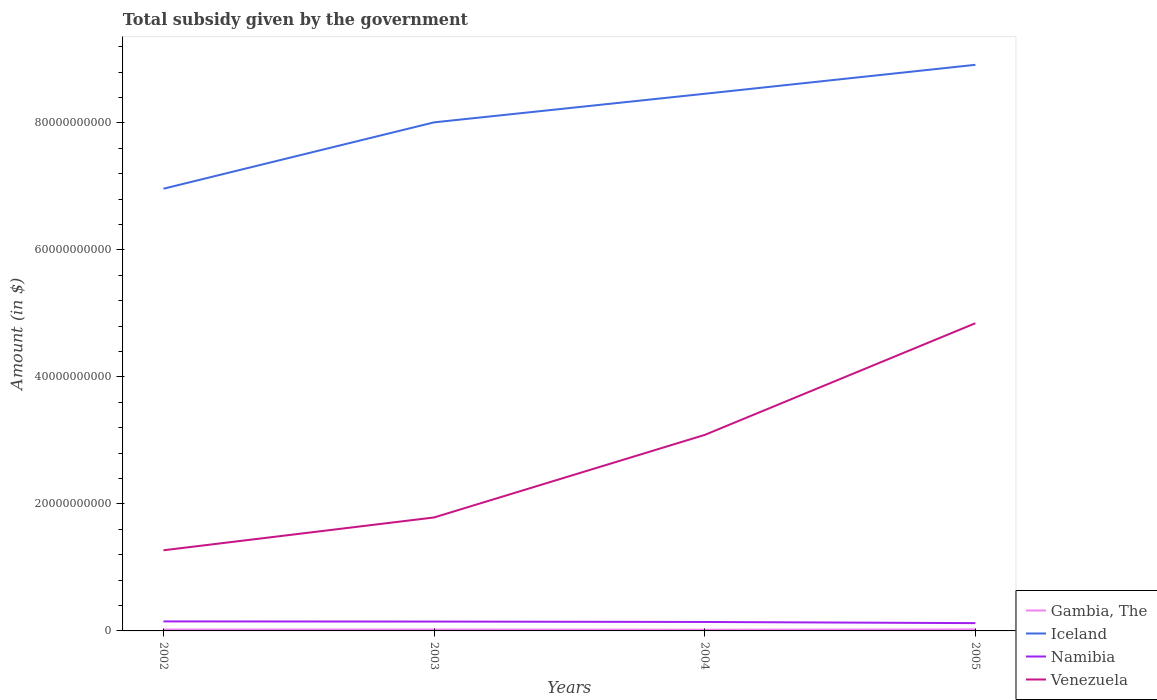How many different coloured lines are there?
Provide a succinct answer. 4. Across all years, what is the maximum total revenue collected by the government in Namibia?
Offer a terse response. 1.23e+09. In which year was the total revenue collected by the government in Venezuela maximum?
Offer a terse response. 2002. What is the total total revenue collected by the government in Gambia, The in the graph?
Your answer should be compact. -4.70e+06. What is the difference between the highest and the second highest total revenue collected by the government in Venezuela?
Your answer should be compact. 3.58e+1. Where does the legend appear in the graph?
Provide a short and direct response. Bottom right. How many legend labels are there?
Your answer should be very brief. 4. How are the legend labels stacked?
Give a very brief answer. Vertical. What is the title of the graph?
Your answer should be very brief. Total subsidy given by the government. Does "Macedonia" appear as one of the legend labels in the graph?
Make the answer very short. No. What is the label or title of the X-axis?
Offer a terse response. Years. What is the label or title of the Y-axis?
Your answer should be very brief. Amount (in $). What is the Amount (in $) in Gambia, The in 2002?
Your answer should be compact. 2.17e+08. What is the Amount (in $) in Iceland in 2002?
Keep it short and to the point. 6.96e+1. What is the Amount (in $) of Namibia in 2002?
Make the answer very short. 1.50e+09. What is the Amount (in $) in Venezuela in 2002?
Make the answer very short. 1.27e+1. What is the Amount (in $) in Gambia, The in 2003?
Keep it short and to the point. 2.22e+08. What is the Amount (in $) of Iceland in 2003?
Provide a succinct answer. 8.01e+1. What is the Amount (in $) in Namibia in 2003?
Offer a very short reply. 1.47e+09. What is the Amount (in $) in Venezuela in 2003?
Make the answer very short. 1.79e+1. What is the Amount (in $) in Gambia, The in 2004?
Your answer should be very brief. 1.91e+08. What is the Amount (in $) of Iceland in 2004?
Your answer should be very brief. 8.46e+1. What is the Amount (in $) in Namibia in 2004?
Make the answer very short. 1.41e+09. What is the Amount (in $) in Venezuela in 2004?
Ensure brevity in your answer.  3.09e+1. What is the Amount (in $) of Gambia, The in 2005?
Offer a very short reply. 2.31e+08. What is the Amount (in $) in Iceland in 2005?
Provide a succinct answer. 8.92e+1. What is the Amount (in $) of Namibia in 2005?
Provide a short and direct response. 1.23e+09. What is the Amount (in $) in Venezuela in 2005?
Provide a short and direct response. 4.85e+1. Across all years, what is the maximum Amount (in $) of Gambia, The?
Keep it short and to the point. 2.31e+08. Across all years, what is the maximum Amount (in $) of Iceland?
Your response must be concise. 8.92e+1. Across all years, what is the maximum Amount (in $) in Namibia?
Your answer should be very brief. 1.50e+09. Across all years, what is the maximum Amount (in $) in Venezuela?
Offer a very short reply. 4.85e+1. Across all years, what is the minimum Amount (in $) of Gambia, The?
Offer a very short reply. 1.91e+08. Across all years, what is the minimum Amount (in $) in Iceland?
Ensure brevity in your answer.  6.96e+1. Across all years, what is the minimum Amount (in $) in Namibia?
Give a very brief answer. 1.23e+09. Across all years, what is the minimum Amount (in $) of Venezuela?
Offer a very short reply. 1.27e+1. What is the total Amount (in $) of Gambia, The in the graph?
Make the answer very short. 8.60e+08. What is the total Amount (in $) of Iceland in the graph?
Provide a short and direct response. 3.23e+11. What is the total Amount (in $) in Namibia in the graph?
Give a very brief answer. 5.61e+09. What is the total Amount (in $) in Venezuela in the graph?
Your answer should be compact. 1.10e+11. What is the difference between the Amount (in $) of Gambia, The in 2002 and that in 2003?
Your response must be concise. -4.70e+06. What is the difference between the Amount (in $) of Iceland in 2002 and that in 2003?
Provide a short and direct response. -1.05e+1. What is the difference between the Amount (in $) of Namibia in 2002 and that in 2003?
Offer a very short reply. 2.49e+07. What is the difference between the Amount (in $) of Venezuela in 2002 and that in 2003?
Keep it short and to the point. -5.17e+09. What is the difference between the Amount (in $) of Gambia, The in 2002 and that in 2004?
Your response must be concise. 2.61e+07. What is the difference between the Amount (in $) of Iceland in 2002 and that in 2004?
Offer a very short reply. -1.50e+1. What is the difference between the Amount (in $) of Namibia in 2002 and that in 2004?
Your answer should be compact. 8.79e+07. What is the difference between the Amount (in $) in Venezuela in 2002 and that in 2004?
Offer a terse response. -1.82e+1. What is the difference between the Amount (in $) of Gambia, The in 2002 and that in 2005?
Keep it short and to the point. -1.37e+07. What is the difference between the Amount (in $) in Iceland in 2002 and that in 2005?
Offer a terse response. -1.95e+1. What is the difference between the Amount (in $) in Namibia in 2002 and that in 2005?
Make the answer very short. 2.69e+08. What is the difference between the Amount (in $) of Venezuela in 2002 and that in 2005?
Your response must be concise. -3.58e+1. What is the difference between the Amount (in $) in Gambia, The in 2003 and that in 2004?
Offer a terse response. 3.08e+07. What is the difference between the Amount (in $) of Iceland in 2003 and that in 2004?
Your response must be concise. -4.50e+09. What is the difference between the Amount (in $) of Namibia in 2003 and that in 2004?
Make the answer very short. 6.31e+07. What is the difference between the Amount (in $) in Venezuela in 2003 and that in 2004?
Your answer should be compact. -1.30e+1. What is the difference between the Amount (in $) in Gambia, The in 2003 and that in 2005?
Your answer should be compact. -9.00e+06. What is the difference between the Amount (in $) in Iceland in 2003 and that in 2005?
Keep it short and to the point. -9.06e+09. What is the difference between the Amount (in $) of Namibia in 2003 and that in 2005?
Offer a terse response. 2.44e+08. What is the difference between the Amount (in $) of Venezuela in 2003 and that in 2005?
Give a very brief answer. -3.06e+1. What is the difference between the Amount (in $) in Gambia, The in 2004 and that in 2005?
Your response must be concise. -3.98e+07. What is the difference between the Amount (in $) of Iceland in 2004 and that in 2005?
Offer a terse response. -4.56e+09. What is the difference between the Amount (in $) in Namibia in 2004 and that in 2005?
Provide a succinct answer. 1.81e+08. What is the difference between the Amount (in $) in Venezuela in 2004 and that in 2005?
Your answer should be compact. -1.76e+1. What is the difference between the Amount (in $) of Gambia, The in 2002 and the Amount (in $) of Iceland in 2003?
Your answer should be compact. -7.99e+1. What is the difference between the Amount (in $) of Gambia, The in 2002 and the Amount (in $) of Namibia in 2003?
Provide a short and direct response. -1.26e+09. What is the difference between the Amount (in $) of Gambia, The in 2002 and the Amount (in $) of Venezuela in 2003?
Make the answer very short. -1.77e+1. What is the difference between the Amount (in $) in Iceland in 2002 and the Amount (in $) in Namibia in 2003?
Your answer should be very brief. 6.82e+1. What is the difference between the Amount (in $) of Iceland in 2002 and the Amount (in $) of Venezuela in 2003?
Give a very brief answer. 5.18e+1. What is the difference between the Amount (in $) in Namibia in 2002 and the Amount (in $) in Venezuela in 2003?
Provide a succinct answer. -1.64e+1. What is the difference between the Amount (in $) in Gambia, The in 2002 and the Amount (in $) in Iceland in 2004?
Your answer should be very brief. -8.44e+1. What is the difference between the Amount (in $) of Gambia, The in 2002 and the Amount (in $) of Namibia in 2004?
Your response must be concise. -1.19e+09. What is the difference between the Amount (in $) in Gambia, The in 2002 and the Amount (in $) in Venezuela in 2004?
Provide a succinct answer. -3.07e+1. What is the difference between the Amount (in $) in Iceland in 2002 and the Amount (in $) in Namibia in 2004?
Make the answer very short. 6.82e+1. What is the difference between the Amount (in $) of Iceland in 2002 and the Amount (in $) of Venezuela in 2004?
Provide a short and direct response. 3.88e+1. What is the difference between the Amount (in $) of Namibia in 2002 and the Amount (in $) of Venezuela in 2004?
Make the answer very short. -2.94e+1. What is the difference between the Amount (in $) in Gambia, The in 2002 and the Amount (in $) in Iceland in 2005?
Your answer should be very brief. -8.89e+1. What is the difference between the Amount (in $) in Gambia, The in 2002 and the Amount (in $) in Namibia in 2005?
Provide a succinct answer. -1.01e+09. What is the difference between the Amount (in $) in Gambia, The in 2002 and the Amount (in $) in Venezuela in 2005?
Offer a very short reply. -4.82e+1. What is the difference between the Amount (in $) of Iceland in 2002 and the Amount (in $) of Namibia in 2005?
Provide a short and direct response. 6.84e+1. What is the difference between the Amount (in $) in Iceland in 2002 and the Amount (in $) in Venezuela in 2005?
Keep it short and to the point. 2.12e+1. What is the difference between the Amount (in $) in Namibia in 2002 and the Amount (in $) in Venezuela in 2005?
Offer a terse response. -4.70e+1. What is the difference between the Amount (in $) in Gambia, The in 2003 and the Amount (in $) in Iceland in 2004?
Offer a very short reply. -8.44e+1. What is the difference between the Amount (in $) of Gambia, The in 2003 and the Amount (in $) of Namibia in 2004?
Provide a short and direct response. -1.19e+09. What is the difference between the Amount (in $) of Gambia, The in 2003 and the Amount (in $) of Venezuela in 2004?
Give a very brief answer. -3.06e+1. What is the difference between the Amount (in $) of Iceland in 2003 and the Amount (in $) of Namibia in 2004?
Ensure brevity in your answer.  7.87e+1. What is the difference between the Amount (in $) in Iceland in 2003 and the Amount (in $) in Venezuela in 2004?
Provide a succinct answer. 4.92e+1. What is the difference between the Amount (in $) in Namibia in 2003 and the Amount (in $) in Venezuela in 2004?
Provide a succinct answer. -2.94e+1. What is the difference between the Amount (in $) of Gambia, The in 2003 and the Amount (in $) of Iceland in 2005?
Your answer should be compact. -8.89e+1. What is the difference between the Amount (in $) in Gambia, The in 2003 and the Amount (in $) in Namibia in 2005?
Offer a very short reply. -1.01e+09. What is the difference between the Amount (in $) in Gambia, The in 2003 and the Amount (in $) in Venezuela in 2005?
Offer a terse response. -4.82e+1. What is the difference between the Amount (in $) in Iceland in 2003 and the Amount (in $) in Namibia in 2005?
Your answer should be very brief. 7.89e+1. What is the difference between the Amount (in $) of Iceland in 2003 and the Amount (in $) of Venezuela in 2005?
Offer a very short reply. 3.16e+1. What is the difference between the Amount (in $) in Namibia in 2003 and the Amount (in $) in Venezuela in 2005?
Provide a succinct answer. -4.70e+1. What is the difference between the Amount (in $) of Gambia, The in 2004 and the Amount (in $) of Iceland in 2005?
Provide a succinct answer. -8.90e+1. What is the difference between the Amount (in $) in Gambia, The in 2004 and the Amount (in $) in Namibia in 2005?
Your answer should be very brief. -1.04e+09. What is the difference between the Amount (in $) in Gambia, The in 2004 and the Amount (in $) in Venezuela in 2005?
Offer a very short reply. -4.83e+1. What is the difference between the Amount (in $) of Iceland in 2004 and the Amount (in $) of Namibia in 2005?
Offer a terse response. 8.34e+1. What is the difference between the Amount (in $) of Iceland in 2004 and the Amount (in $) of Venezuela in 2005?
Make the answer very short. 3.61e+1. What is the difference between the Amount (in $) of Namibia in 2004 and the Amount (in $) of Venezuela in 2005?
Provide a succinct answer. -4.70e+1. What is the average Amount (in $) of Gambia, The per year?
Provide a succinct answer. 2.15e+08. What is the average Amount (in $) in Iceland per year?
Provide a succinct answer. 8.09e+1. What is the average Amount (in $) in Namibia per year?
Your answer should be compact. 1.40e+09. What is the average Amount (in $) in Venezuela per year?
Your answer should be very brief. 2.75e+1. In the year 2002, what is the difference between the Amount (in $) in Gambia, The and Amount (in $) in Iceland?
Offer a very short reply. -6.94e+1. In the year 2002, what is the difference between the Amount (in $) in Gambia, The and Amount (in $) in Namibia?
Keep it short and to the point. -1.28e+09. In the year 2002, what is the difference between the Amount (in $) in Gambia, The and Amount (in $) in Venezuela?
Ensure brevity in your answer.  -1.25e+1. In the year 2002, what is the difference between the Amount (in $) of Iceland and Amount (in $) of Namibia?
Your response must be concise. 6.81e+1. In the year 2002, what is the difference between the Amount (in $) in Iceland and Amount (in $) in Venezuela?
Give a very brief answer. 5.69e+1. In the year 2002, what is the difference between the Amount (in $) in Namibia and Amount (in $) in Venezuela?
Provide a short and direct response. -1.12e+1. In the year 2003, what is the difference between the Amount (in $) in Gambia, The and Amount (in $) in Iceland?
Your response must be concise. -7.99e+1. In the year 2003, what is the difference between the Amount (in $) in Gambia, The and Amount (in $) in Namibia?
Offer a very short reply. -1.25e+09. In the year 2003, what is the difference between the Amount (in $) of Gambia, The and Amount (in $) of Venezuela?
Your response must be concise. -1.76e+1. In the year 2003, what is the difference between the Amount (in $) in Iceland and Amount (in $) in Namibia?
Ensure brevity in your answer.  7.86e+1. In the year 2003, what is the difference between the Amount (in $) of Iceland and Amount (in $) of Venezuela?
Keep it short and to the point. 6.22e+1. In the year 2003, what is the difference between the Amount (in $) in Namibia and Amount (in $) in Venezuela?
Provide a succinct answer. -1.64e+1. In the year 2004, what is the difference between the Amount (in $) of Gambia, The and Amount (in $) of Iceland?
Keep it short and to the point. -8.44e+1. In the year 2004, what is the difference between the Amount (in $) of Gambia, The and Amount (in $) of Namibia?
Give a very brief answer. -1.22e+09. In the year 2004, what is the difference between the Amount (in $) in Gambia, The and Amount (in $) in Venezuela?
Ensure brevity in your answer.  -3.07e+1. In the year 2004, what is the difference between the Amount (in $) of Iceland and Amount (in $) of Namibia?
Offer a terse response. 8.32e+1. In the year 2004, what is the difference between the Amount (in $) of Iceland and Amount (in $) of Venezuela?
Your answer should be compact. 5.37e+1. In the year 2004, what is the difference between the Amount (in $) of Namibia and Amount (in $) of Venezuela?
Offer a terse response. -2.95e+1. In the year 2005, what is the difference between the Amount (in $) in Gambia, The and Amount (in $) in Iceland?
Your answer should be very brief. -8.89e+1. In the year 2005, what is the difference between the Amount (in $) of Gambia, The and Amount (in $) of Namibia?
Your answer should be very brief. -9.98e+08. In the year 2005, what is the difference between the Amount (in $) of Gambia, The and Amount (in $) of Venezuela?
Ensure brevity in your answer.  -4.82e+1. In the year 2005, what is the difference between the Amount (in $) of Iceland and Amount (in $) of Namibia?
Keep it short and to the point. 8.79e+1. In the year 2005, what is the difference between the Amount (in $) of Iceland and Amount (in $) of Venezuela?
Your response must be concise. 4.07e+1. In the year 2005, what is the difference between the Amount (in $) of Namibia and Amount (in $) of Venezuela?
Your answer should be very brief. -4.72e+1. What is the ratio of the Amount (in $) in Gambia, The in 2002 to that in 2003?
Your response must be concise. 0.98. What is the ratio of the Amount (in $) of Iceland in 2002 to that in 2003?
Keep it short and to the point. 0.87. What is the ratio of the Amount (in $) in Namibia in 2002 to that in 2003?
Your response must be concise. 1.02. What is the ratio of the Amount (in $) in Venezuela in 2002 to that in 2003?
Your response must be concise. 0.71. What is the ratio of the Amount (in $) in Gambia, The in 2002 to that in 2004?
Provide a short and direct response. 1.14. What is the ratio of the Amount (in $) in Iceland in 2002 to that in 2004?
Offer a very short reply. 0.82. What is the ratio of the Amount (in $) in Namibia in 2002 to that in 2004?
Give a very brief answer. 1.06. What is the ratio of the Amount (in $) in Venezuela in 2002 to that in 2004?
Provide a short and direct response. 0.41. What is the ratio of the Amount (in $) of Gambia, The in 2002 to that in 2005?
Give a very brief answer. 0.94. What is the ratio of the Amount (in $) of Iceland in 2002 to that in 2005?
Give a very brief answer. 0.78. What is the ratio of the Amount (in $) in Namibia in 2002 to that in 2005?
Provide a succinct answer. 1.22. What is the ratio of the Amount (in $) of Venezuela in 2002 to that in 2005?
Your answer should be compact. 0.26. What is the ratio of the Amount (in $) of Gambia, The in 2003 to that in 2004?
Keep it short and to the point. 1.16. What is the ratio of the Amount (in $) in Iceland in 2003 to that in 2004?
Keep it short and to the point. 0.95. What is the ratio of the Amount (in $) of Namibia in 2003 to that in 2004?
Ensure brevity in your answer.  1.04. What is the ratio of the Amount (in $) in Venezuela in 2003 to that in 2004?
Ensure brevity in your answer.  0.58. What is the ratio of the Amount (in $) of Iceland in 2003 to that in 2005?
Make the answer very short. 0.9. What is the ratio of the Amount (in $) of Namibia in 2003 to that in 2005?
Your answer should be compact. 1.2. What is the ratio of the Amount (in $) in Venezuela in 2003 to that in 2005?
Keep it short and to the point. 0.37. What is the ratio of the Amount (in $) of Gambia, The in 2004 to that in 2005?
Your answer should be compact. 0.83. What is the ratio of the Amount (in $) of Iceland in 2004 to that in 2005?
Ensure brevity in your answer.  0.95. What is the ratio of the Amount (in $) in Namibia in 2004 to that in 2005?
Your answer should be very brief. 1.15. What is the ratio of the Amount (in $) of Venezuela in 2004 to that in 2005?
Your answer should be compact. 0.64. What is the difference between the highest and the second highest Amount (in $) of Gambia, The?
Provide a short and direct response. 9.00e+06. What is the difference between the highest and the second highest Amount (in $) in Iceland?
Make the answer very short. 4.56e+09. What is the difference between the highest and the second highest Amount (in $) in Namibia?
Provide a short and direct response. 2.49e+07. What is the difference between the highest and the second highest Amount (in $) in Venezuela?
Make the answer very short. 1.76e+1. What is the difference between the highest and the lowest Amount (in $) of Gambia, The?
Provide a short and direct response. 3.98e+07. What is the difference between the highest and the lowest Amount (in $) in Iceland?
Offer a very short reply. 1.95e+1. What is the difference between the highest and the lowest Amount (in $) of Namibia?
Your answer should be very brief. 2.69e+08. What is the difference between the highest and the lowest Amount (in $) of Venezuela?
Offer a terse response. 3.58e+1. 